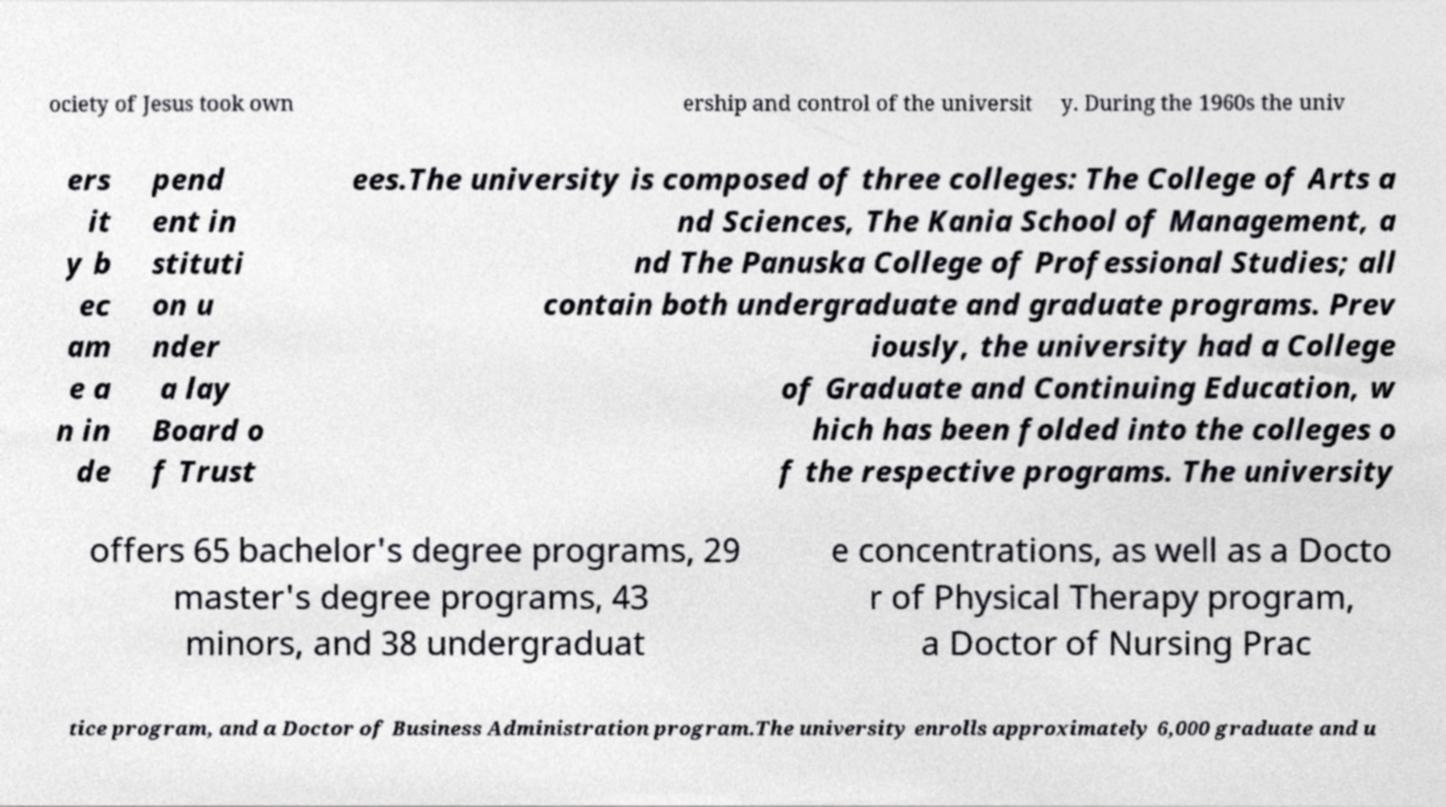Can you read and provide the text displayed in the image?This photo seems to have some interesting text. Can you extract and type it out for me? ociety of Jesus took own ership and control of the universit y. During the 1960s the univ ers it y b ec am e a n in de pend ent in stituti on u nder a lay Board o f Trust ees.The university is composed of three colleges: The College of Arts a nd Sciences, The Kania School of Management, a nd The Panuska College of Professional Studies; all contain both undergraduate and graduate programs. Prev iously, the university had a College of Graduate and Continuing Education, w hich has been folded into the colleges o f the respective programs. The university offers 65 bachelor's degree programs, 29 master's degree programs, 43 minors, and 38 undergraduat e concentrations, as well as a Docto r of Physical Therapy program, a Doctor of Nursing Prac tice program, and a Doctor of Business Administration program.The university enrolls approximately 6,000 graduate and u 